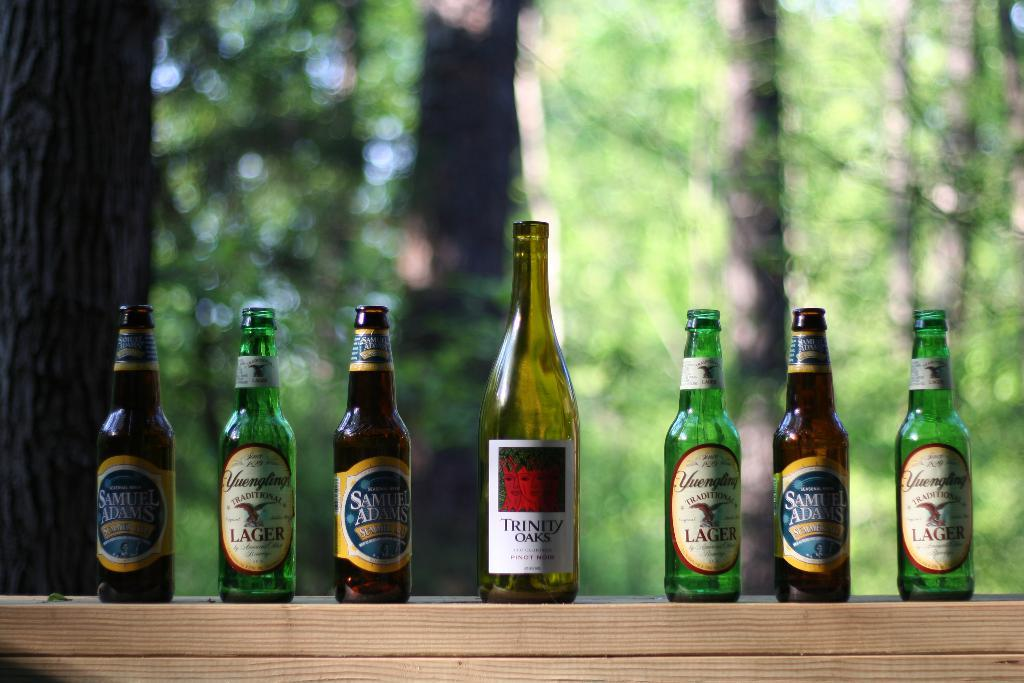<image>
Give a short and clear explanation of the subsequent image. Bottles of beer are lined up with a single bottle of Trinity Oaks wine in the center. 